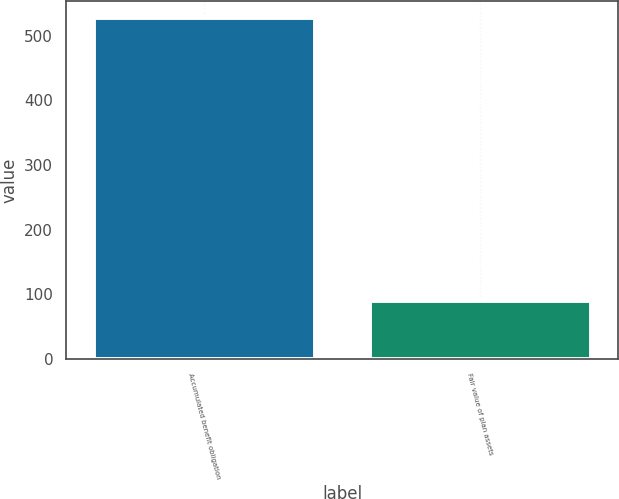<chart> <loc_0><loc_0><loc_500><loc_500><bar_chart><fcel>Accumulated benefit obligation<fcel>Fair value of plan assets<nl><fcel>527<fcel>90<nl></chart> 